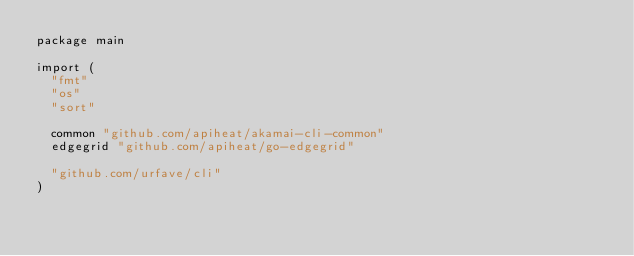<code> <loc_0><loc_0><loc_500><loc_500><_Go_>package main

import (
	"fmt"
	"os"
	"sort"

	common "github.com/apiheat/akamai-cli-common"
	edgegrid "github.com/apiheat/go-edgegrid"

	"github.com/urfave/cli"
)
</code> 